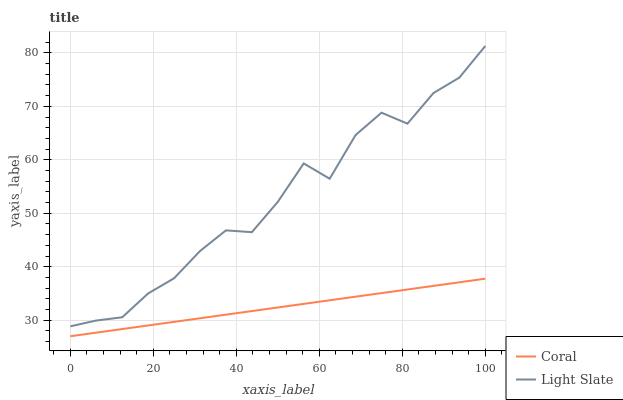Does Coral have the minimum area under the curve?
Answer yes or no. Yes. Does Light Slate have the maximum area under the curve?
Answer yes or no. Yes. Does Coral have the maximum area under the curve?
Answer yes or no. No. Is Coral the smoothest?
Answer yes or no. Yes. Is Light Slate the roughest?
Answer yes or no. Yes. Is Coral the roughest?
Answer yes or no. No. Does Coral have the highest value?
Answer yes or no. No. Is Coral less than Light Slate?
Answer yes or no. Yes. Is Light Slate greater than Coral?
Answer yes or no. Yes. Does Coral intersect Light Slate?
Answer yes or no. No. 